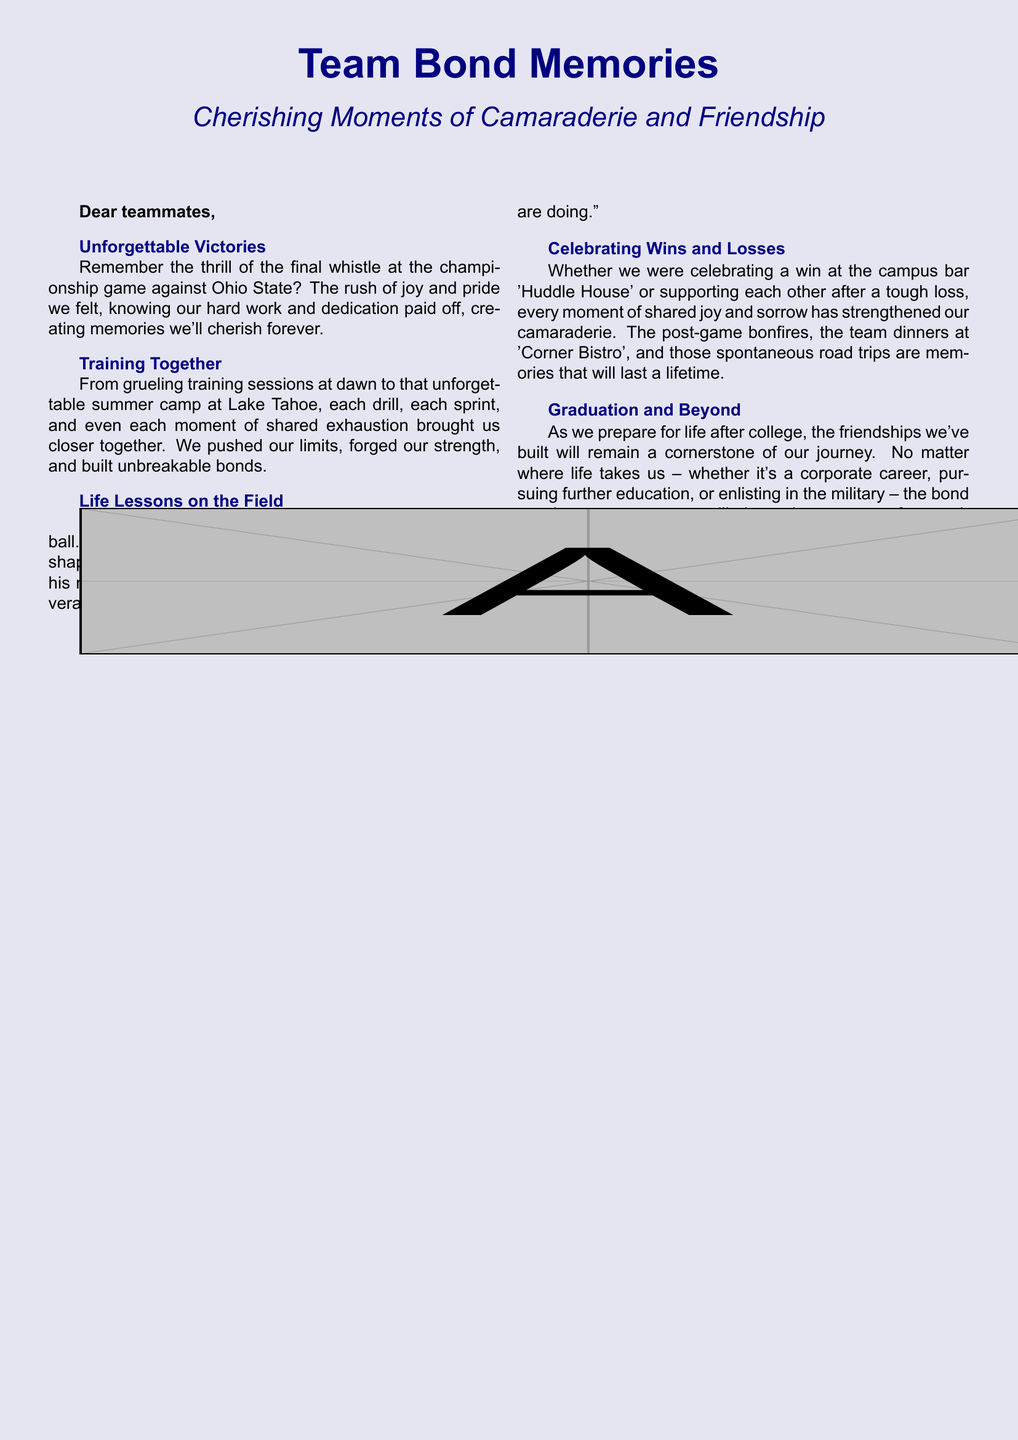What is the title of the card? The title is prominently displayed at the top of the card.
Answer: Team Bond Memories What color is the background of the card? The color of the background is a light shade of navy blue.
Answer: navy blue Which coach's name is mentioned in the document? The document references a specific coach who impacted the team significantly.
Answer: Coach Taylor What memorable event is mentioned against Ohio State? The document describes an important game that the team played.
Answer: championship game What is the name of the bar where the team celebrated wins? A specific location is mentioned where the team gathered after victories.
Answer: Huddle House What mantra did Coach Taylor share with the team? The document includes a specific motivational saying from Coach Taylor.
Answer: Success is no accident. It's hard work, perseverance, learning, sacrifice, and most of all, love of what you are doing What was the location of the memorable summer camp? The document notes a specific place where the team had summer training.
Answer: Lake Tahoe What type of card is this document? The format and content of this document suggest its intended purpose.
Answer: greeting card Which phrase describes the essence of the team's shared experiences? The document uses a specific phrase to encapsulate the team's bond.
Answer: Moments of Camaraderie and Friendship 